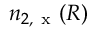Convert formula to latex. <formula><loc_0><loc_0><loc_500><loc_500>n _ { 2 , x } ( R )</formula> 